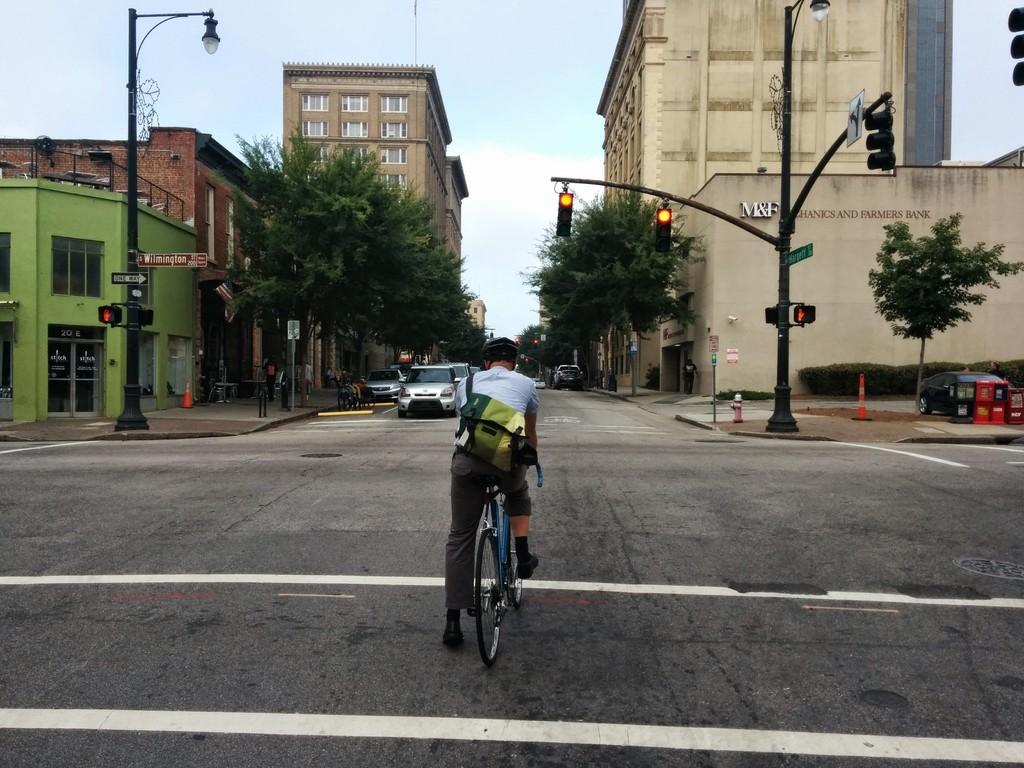Describe this image in one or two sentences. This is an outside view. Here I can see a man is riding the bicycle on the road. In the background there are some cars. On both sides of the road I can see the poles and traffic signal lights. In the background there are some trees and buildings. On the top of the image I can see the sky. 